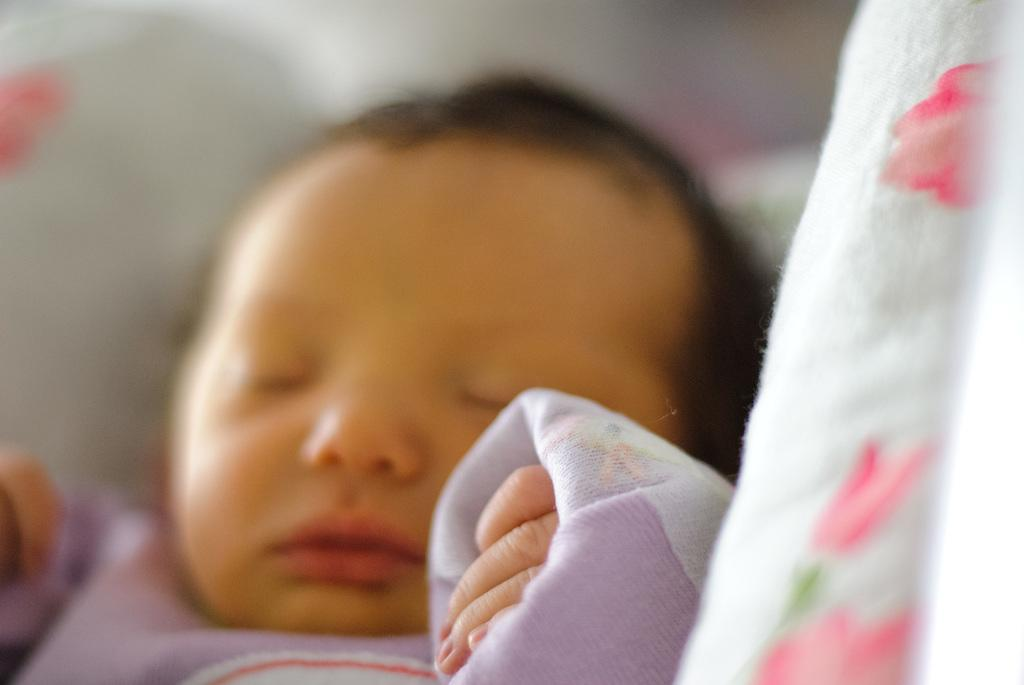What is the main subject of the image? There is a baby in the image. What is the baby doing in the image? The baby is sleeping. Where is the baby located in the image? The baby is on a bed. Can you describe the background of the image? The background at the top of the image is blurred. What type of soup is being cooked on the stove in the image? There is no stove or soup present in the image; it features a baby sleeping on a bed. 